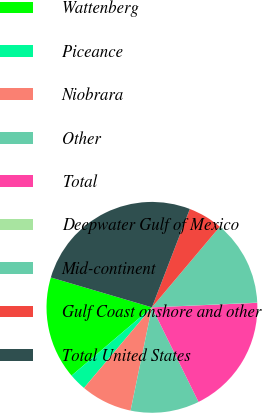<chart> <loc_0><loc_0><loc_500><loc_500><pie_chart><fcel>Wattenberg<fcel>Piceance<fcel>Niobrara<fcel>Other<fcel>Total<fcel>Deepwater Gulf of Mexico<fcel>Mid-continent<fcel>Gulf Coast onshore and other<fcel>Total United States<nl><fcel>15.78%<fcel>2.65%<fcel>7.9%<fcel>10.53%<fcel>18.4%<fcel>0.03%<fcel>13.15%<fcel>5.28%<fcel>26.28%<nl></chart> 